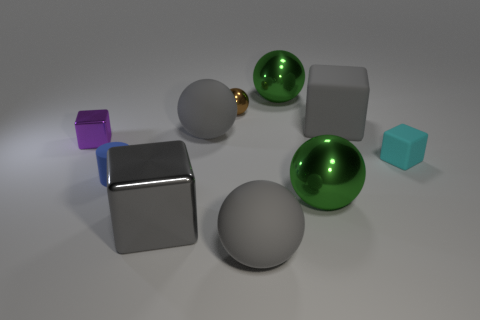Subtract all gray balls. How many were subtracted if there are1gray balls left? 1 Subtract all brown spheres. How many spheres are left? 4 Subtract all tiny balls. How many balls are left? 4 Subtract all yellow balls. Subtract all gray blocks. How many balls are left? 5 Subtract all blocks. How many objects are left? 6 Add 6 blue things. How many blue things exist? 7 Subtract 0 blue spheres. How many objects are left? 10 Subtract all blue things. Subtract all large brown shiny cubes. How many objects are left? 9 Add 2 small cyan blocks. How many small cyan blocks are left? 3 